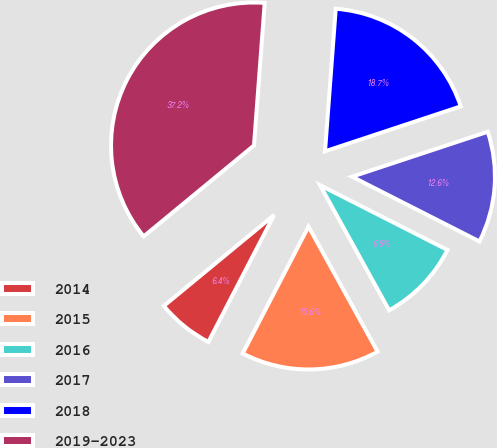<chart> <loc_0><loc_0><loc_500><loc_500><pie_chart><fcel>2014<fcel>2015<fcel>2016<fcel>2017<fcel>2018<fcel>2019-2023<nl><fcel>6.42%<fcel>15.64%<fcel>9.49%<fcel>12.57%<fcel>18.72%<fcel>37.17%<nl></chart> 